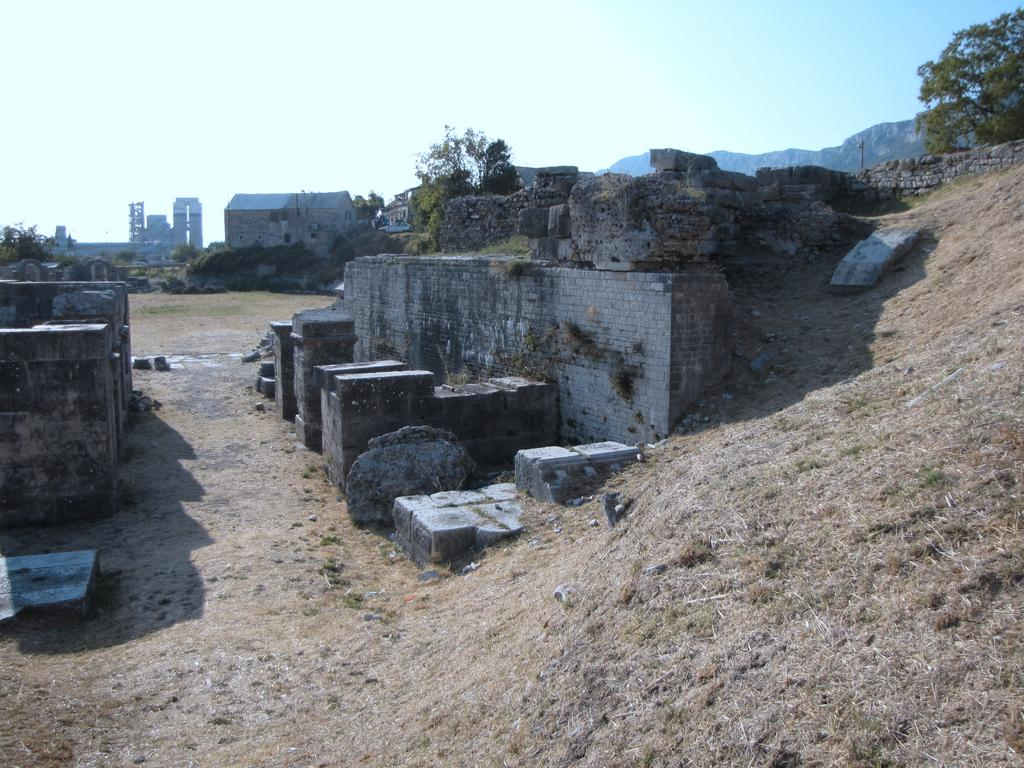What type of structures can be seen in the image? There are buildings in the image. What natural elements are present in the image? There are trees and mountains in the image. What type of terrain is visible in the image? There is dry grass in the image. What is the color of the sky in the image? The sky is in white and blue color. Can you see a gun being used by someone in the image? There is no gun present in the image. Is the father of the person taking the image visible in the image? There is no person taking the image, and therefore no father is visible in the image. 